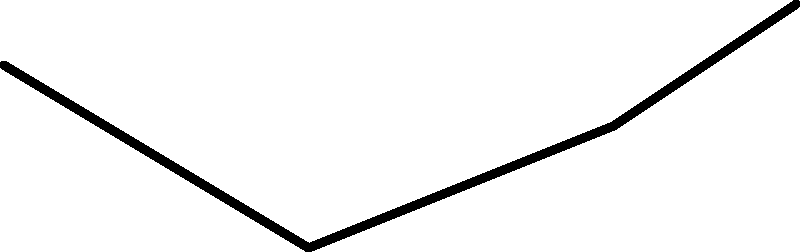In traditional Ripon weaving techniques, what biomechanical principle is demonstrated by the circular motion of the wrist and hand during the weft insertion process, and how does this contribute to the efficiency of the weaving process? 1. The circular motion of the wrist and hand in traditional Ripon weaving demonstrates the principle of conservation of angular momentum.

2. As the weaver moves their hand in a circular path, they create a consistent angular velocity, which is maintained due to the conservation of angular momentum.

3. This circular motion allows for a smooth and continuous insertion of the weft thread through the warp threads.

4. The efficiency is increased because:
   a) The circular motion reduces the need for abrupt changes in direction, minimizing fatigue.
   b) It maintains a constant velocity, allowing for a rhythmic and predictable movement.
   c) The momentum of the circular motion assists in carrying the shuttle or weft thread through the shed.

5. The biomechanical advantage comes from:
   $$\text{Angular Momentum} = I\omega$$
   Where $I$ is the moment of inertia and $\omega$ is the angular velocity.

6. By maintaining a consistent angular momentum, the weaver can work for longer periods with less effort, as the motion becomes more natural and requires less conscious control.

7. This technique also reduces the stress on joints and muscles by distributing the work across a larger range of motion, rather than relying on small, repetitive movements.
Answer: Conservation of angular momentum for efficient, continuous weft insertion. 